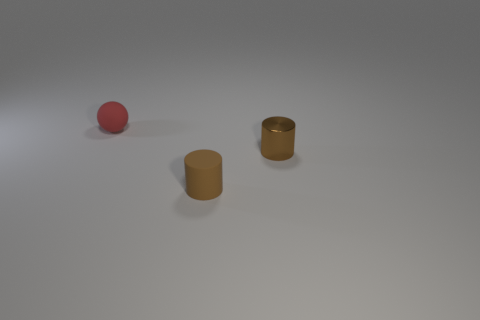What is the size of the rubber object that is the same color as the metallic cylinder?
Provide a succinct answer. Small. Do the matte thing in front of the red sphere and the brown metallic thing have the same size?
Ensure brevity in your answer.  Yes. How many other objects are there of the same shape as the small brown metal object?
Ensure brevity in your answer.  1. Does the small cylinder that is in front of the shiny object have the same color as the shiny cylinder?
Give a very brief answer. Yes. Are there any small metal things that have the same color as the matte cylinder?
Make the answer very short. Yes. What number of red rubber things are left of the tiny ball?
Ensure brevity in your answer.  0. What number of other objects are there of the same size as the rubber sphere?
Provide a succinct answer. 2. Is the material of the tiny brown object on the right side of the small matte cylinder the same as the tiny object that is to the left of the small brown rubber cylinder?
Give a very brief answer. No. The matte cylinder that is the same size as the brown shiny object is what color?
Your answer should be compact. Brown. Are there any other things of the same color as the metal thing?
Offer a very short reply. Yes. 